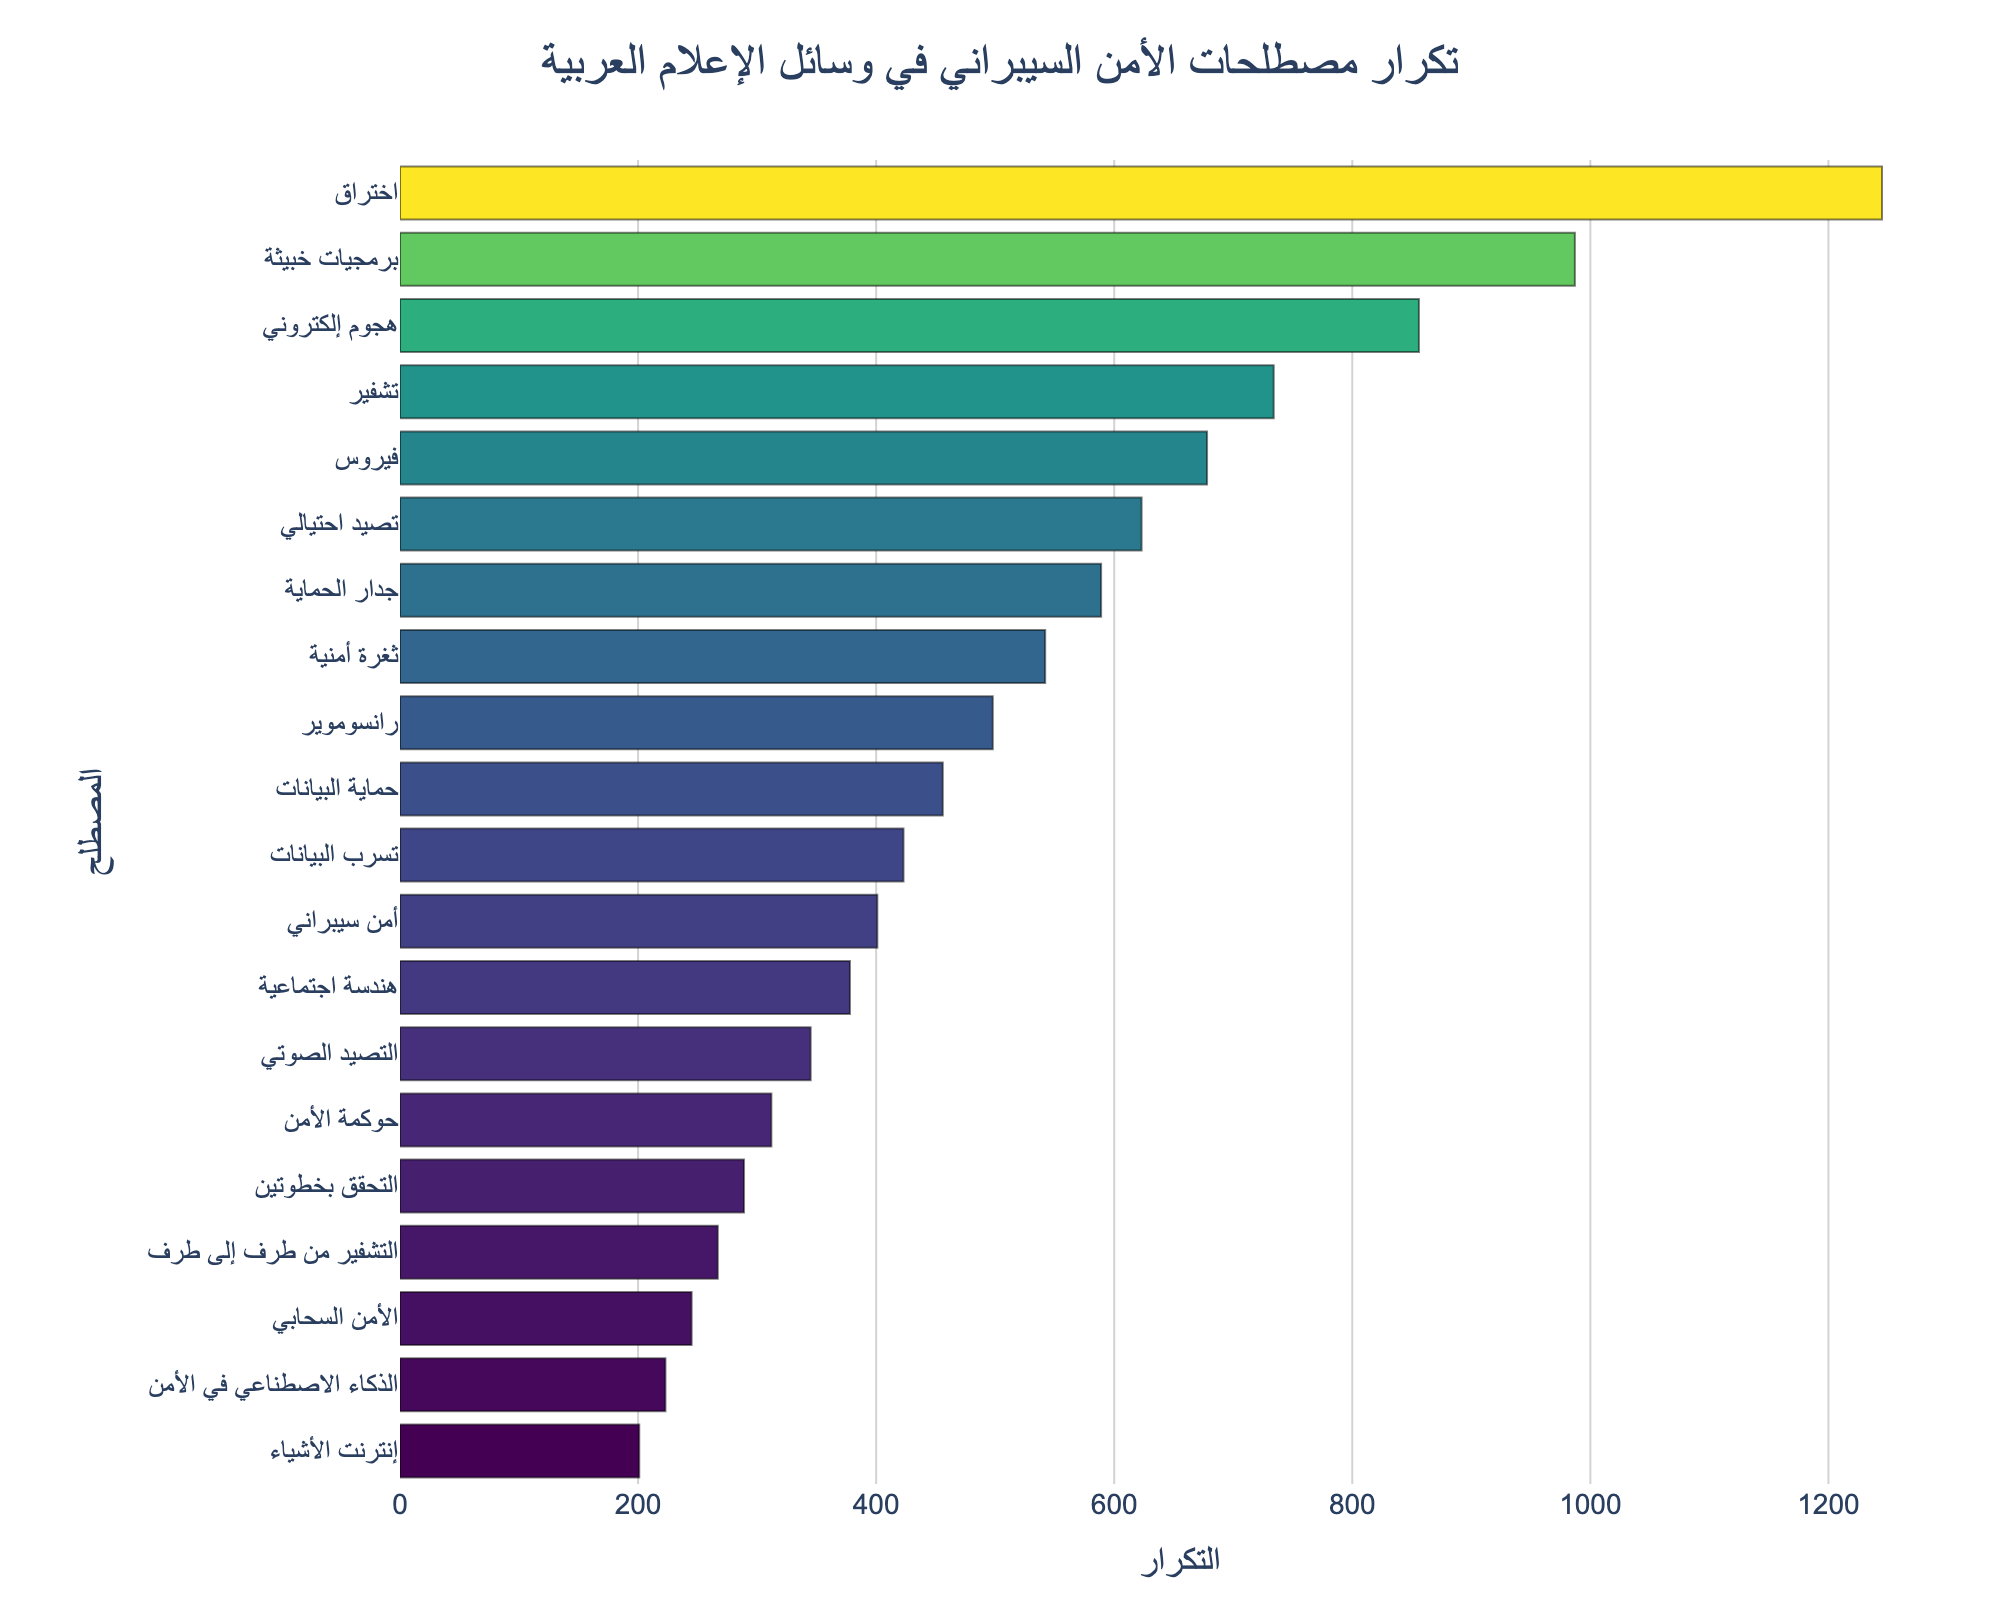Which term has the highest frequency? Look for the term with the longest bar in the chart. The longest bar corresponds to 'اختراق' with a frequency of 1245.
Answer: اختراق Which term has the lowest frequency? Look for the term with the shortest bar in the chart. The shortest bar corresponds to 'إنترنت الأشياء' with a frequency of 201.
Answer: إنترنت الأشياء Compare the frequencies of 'اختراق' and 'برمجيات خبيثة'. Which is higher and by how much? Find the frequencies of both terms ('اختراق' = 1245, 'برمجيات خبيثة' = 987) and subtract the smaller from the larger: 1245 - 987 = 258. 'اختراق' is higher by 258.
Answer: 'اختراق' by 258 What is the combined frequency of 'التشفير من طرف إلى طرف' and 'الذكاء الاصطناعي في الأمن'? Sum the frequencies of 'التشفير من طرف إلى طرف' (267) and 'الذكاء الاصطناعي في الأمن' (223): 267 + 223 = 490.
Answer: 490 Which term related to malicious software has the second-highest frequency? Check terms like 'برمجيات خبيثة' and 'فيروس'. 'برمجيات خبيثة' has the second-highest frequency (987) after 'اختراق'.
Answer: برمجيات خبيثة Is 'التشفير' more frequent than 'رانسوموير'? Compare the frequencies: 'تشفير' = 734, 'رانسوموير' = 498. Since 734 is greater than 498, 'التشفير' is more frequent.
Answer: Yes What is the difference in frequency between the terms with the highest and lowest occurrences? Find the frequency for the highest ('اختراق' = 1245) and lowest ('إنترنت الأشياء' = 201) terms and subtract: 1245 - 201 = 1044.
Answer: 1044 Which term has a frequency closest to 500? Look for terms around the 500 mark in the chart. 'رانسوموير' has a frequency of 498, which is the closest to 500.
Answer: رانسوموير What is the average frequency of 'حوكمة الأمن', 'التحقق بخطوتين', and 'الأمن السحابي'? Find their frequencies ('حوكمة الأمن' = 312, 'التحقق بخطوتين' = 289, 'الأمن السحابي' = 245) and calculate the average: (312 + 289 + 245) / 3 = 846 / 3 = 282.
Answer: 282 Of 'ثغرة أمنية', 'هندسة اجتماعية', and 'التصيد الصوتي', which has the highest frequency? Compare their frequencies: 'ثغرة أمنية' = 542, 'هندسة اجتماعية' = 378, 'التصيد الصوتي' = 345. 'ثغرة أمنية' has the highest frequency.
Answer: ثغرة أمنية 